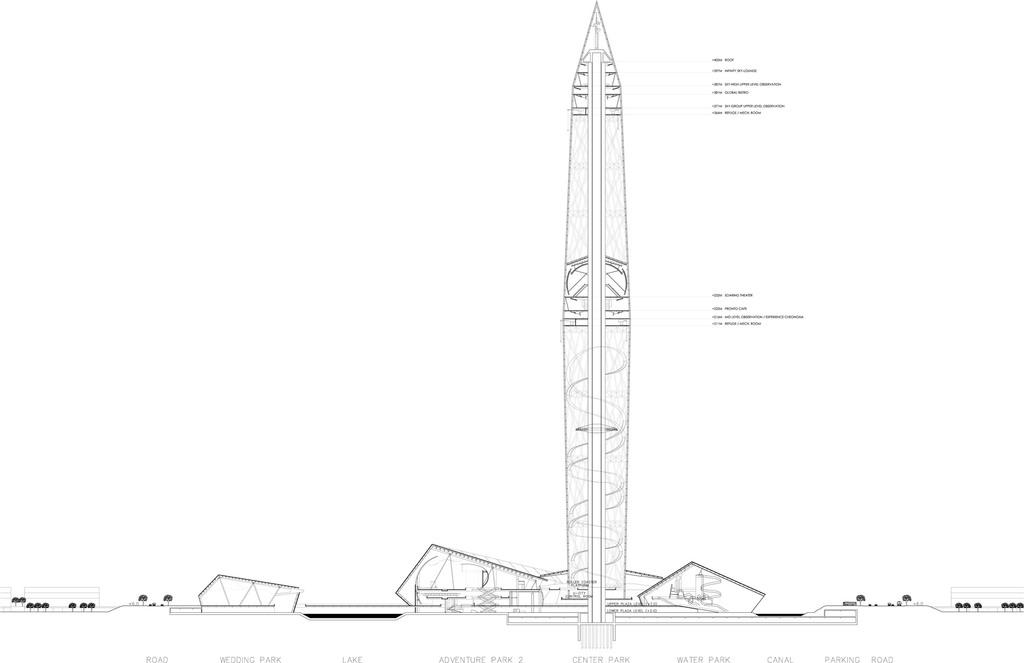What is the main subject of the picture? The main subject of the picture is a missile. How can we identify the different parts of the missile? The different parts of the missile are labelled in the picture. What else can be seen in the picture besides the missile? There are buildings and trees in the picture. What type of scarf is being used to cover the base of the missile in the image? There is no scarf present in the image, nor is there any indication of a base for the missile. 